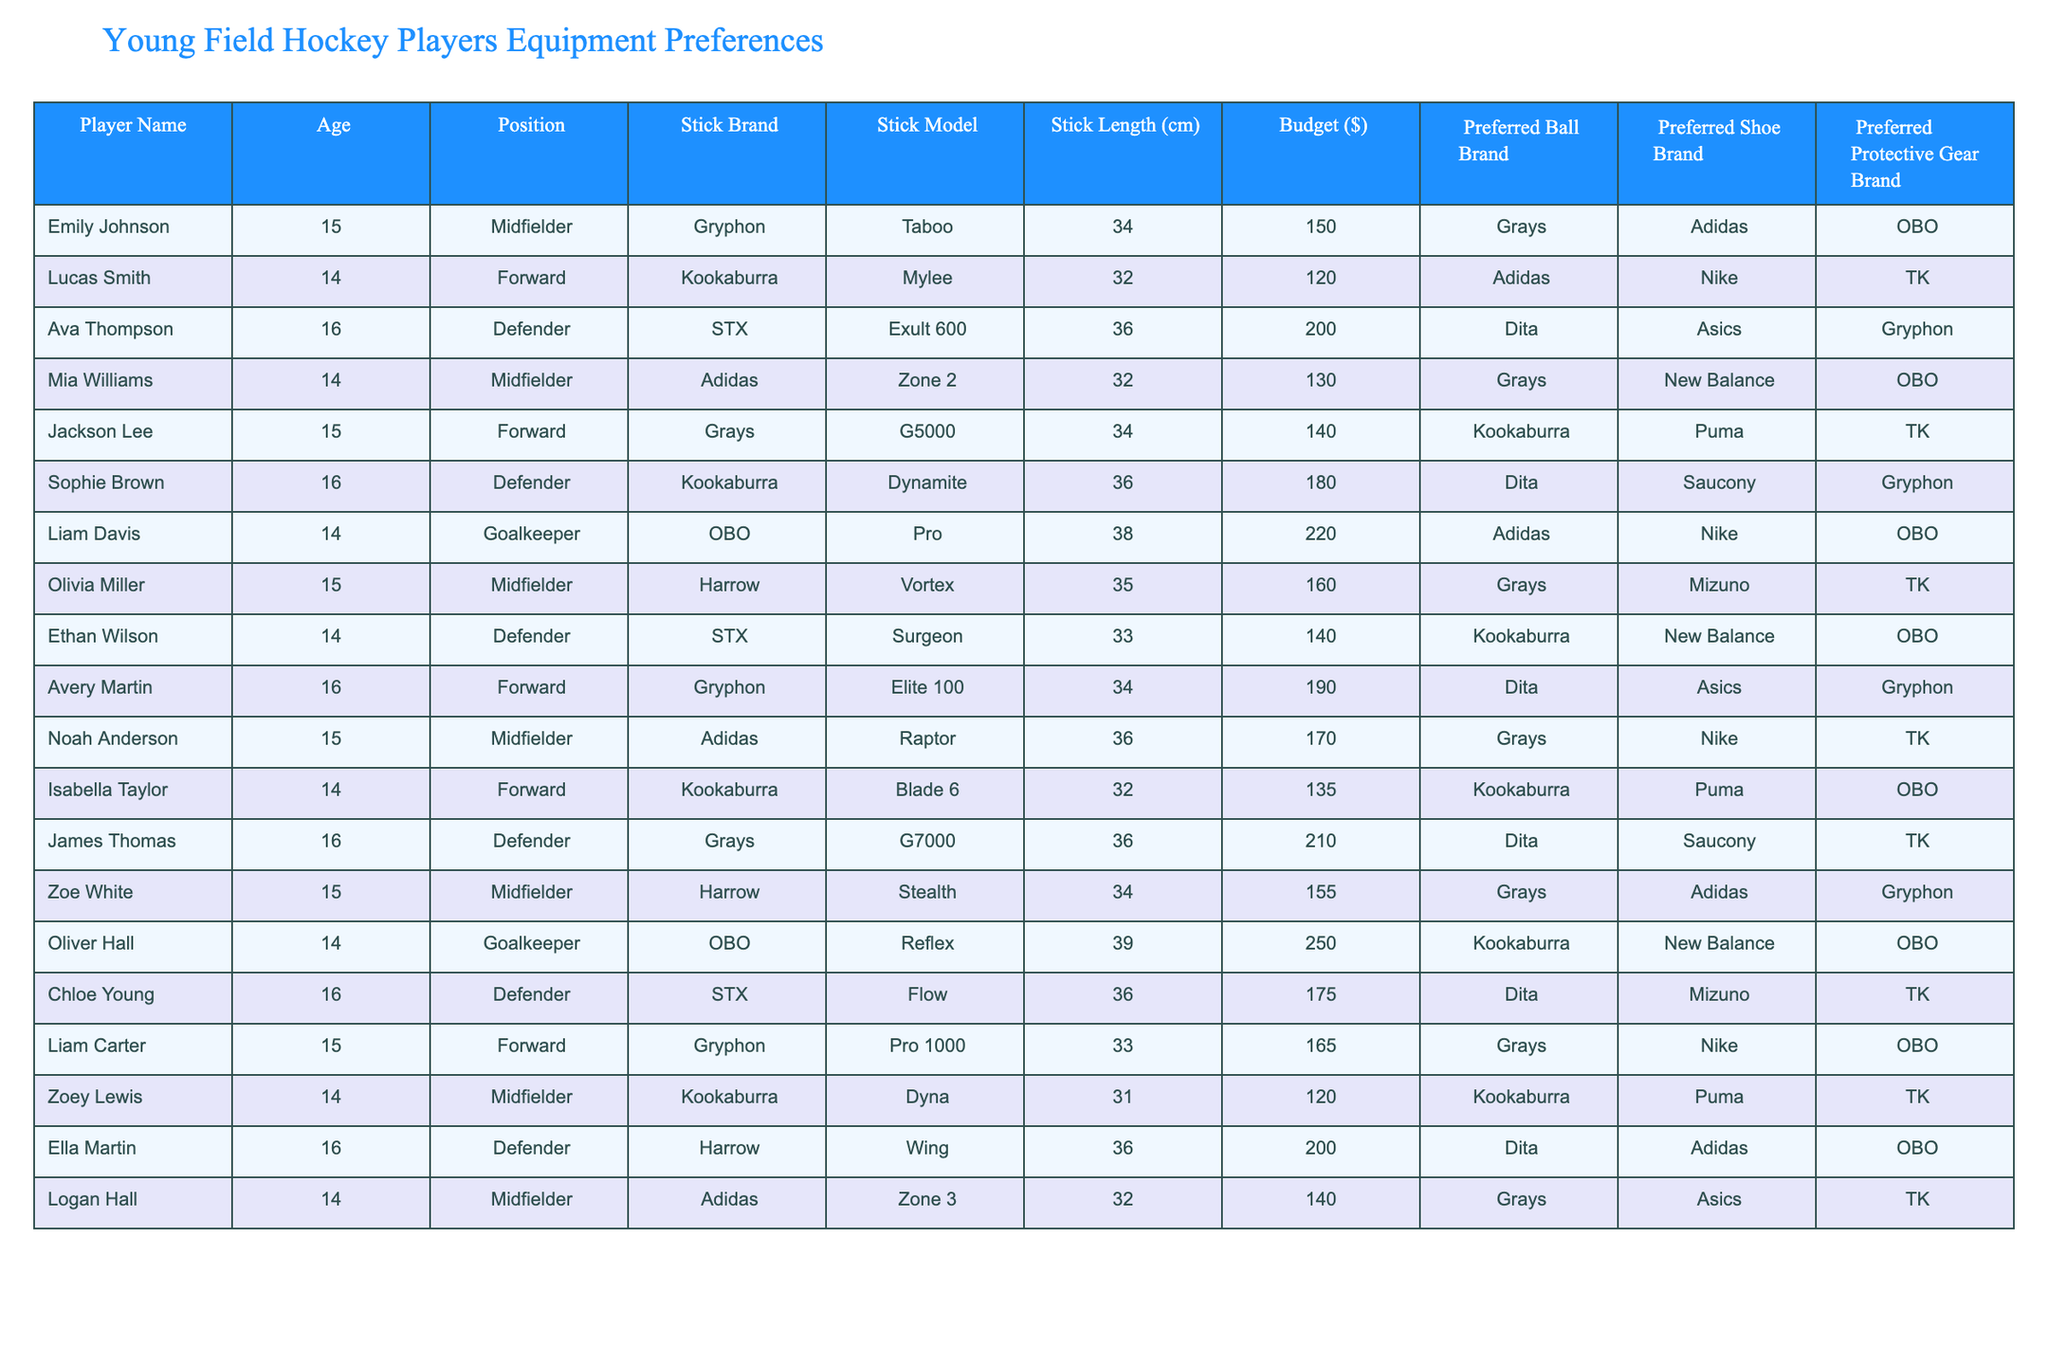What is the budget of the player named Liam Davis? Looking at the table, I find Liam Davis's row and see the budget listed there, which is 220.
Answer: 220 Which player has the highest budget? By examining the budget column, I find that Oliver Hall has a budget of 250.
Answer: 250 What is the average stick length of all players? I sum the stick lengths (34 + 32 + 36 + 32 + 34 + 36 + 38 + 35 + 33 + 34 + 36 + 32 + 36 + 34 + 33 + 36 + 34 + 36 + 36 + 32) = 680 and there are 20 players. So, the average stick length is 680/20 = 34 cm.
Answer: 34 cm Is there any player who has a preferred ball brand of Kookaburra? I go through the preferred ball brand column and see if Kookaburra appears at all. Indeed, both Jackson Lee and Isabella Taylor have Kookaburra as their preferred ball brand.
Answer: Yes What is the stick brand of the player with the highest budget? Looking at the highest budget, which is 250 from Oliver Hall, I check the stick brand column and see that the stick brand for Oliver Hall is OBO.
Answer: OBO How many forwards have a budget above 150? I check the players in the Forward position and find their budgets: Lucas Smith (120), Jackson Lee (140), Avery Martin (190), Liam Carter (165). Only Avery Martin and Liam Carter exceed 150, which makes a total of 2 forwards.
Answer: 2 What is the most common preferred shoe brand among the young players? I cross-reference the preferred shoe brand column and find that Kookaburra appears three times (Lucas Smith, Isabella Taylor, and Zoey Lewis), while Adidas also appears three times (Olivia Miller, Zoe White, and Ella Martin). Therefore, both Kookaburra and Adidas are the most common.
Answer: Kookaburra and Adidas Do any players prefer the same stick brand? I check the stick brand column for repeated entries. Gryphon appears for Emily Johnson, Avery Martin, and Liam Carter, while Kookaburra appears for Lucas Smith, Jackson Lee, Sophie Brown, Isabella Taylor, and Zoey Lewis. Therefore, yes, there are players who prefer the same stick brand.
Answer: Yes What is the total budget of players in the Defender position? I sum the budgets of players in the Defender position: Ava Thompson (200) + Sophie Brown (180) + Ethan Wilson (140) + James Thomas (210) + Chloe Young (175) + Ella Martin (200) = 1105.
Answer: 1105 Which player has the smallest stick length? By looking at the stick length column, I find that Zoey Lewis has the smallest stick length of 31 cm.
Answer: 31 cm 